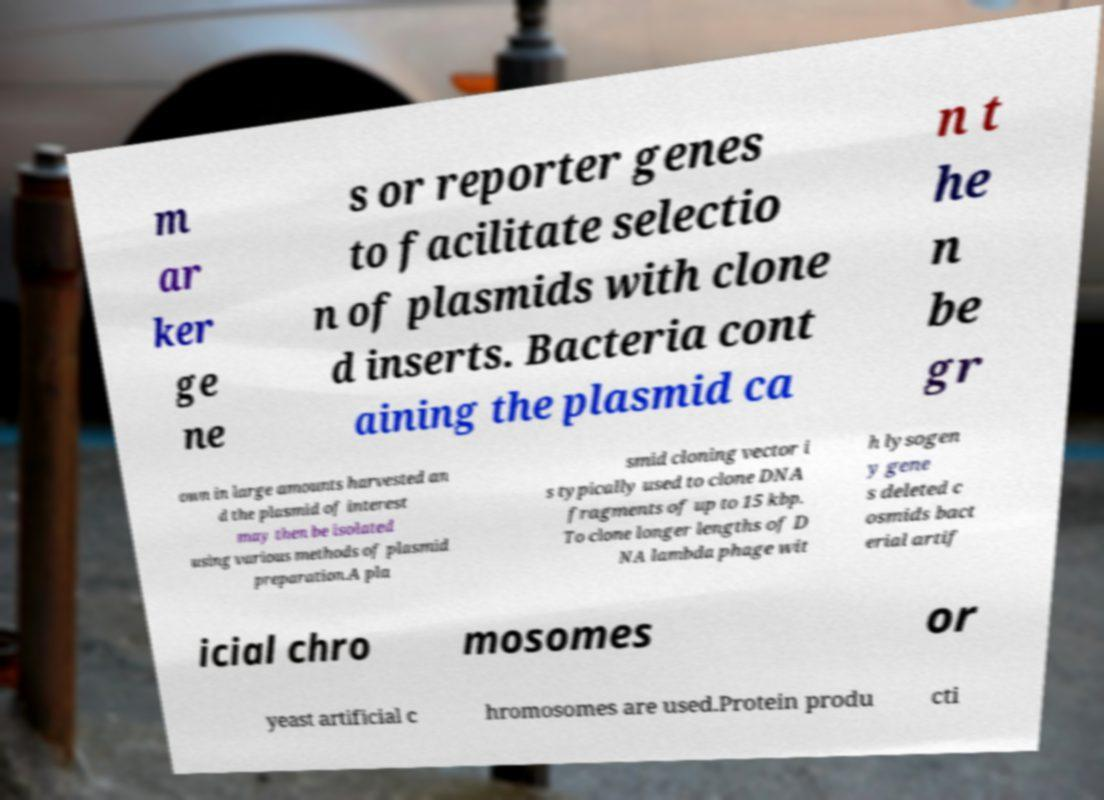Please read and relay the text visible in this image. What does it say? m ar ker ge ne s or reporter genes to facilitate selectio n of plasmids with clone d inserts. Bacteria cont aining the plasmid ca n t he n be gr own in large amounts harvested an d the plasmid of interest may then be isolated using various methods of plasmid preparation.A pla smid cloning vector i s typically used to clone DNA fragments of up to 15 kbp. To clone longer lengths of D NA lambda phage wit h lysogen y gene s deleted c osmids bact erial artif icial chro mosomes or yeast artificial c hromosomes are used.Protein produ cti 